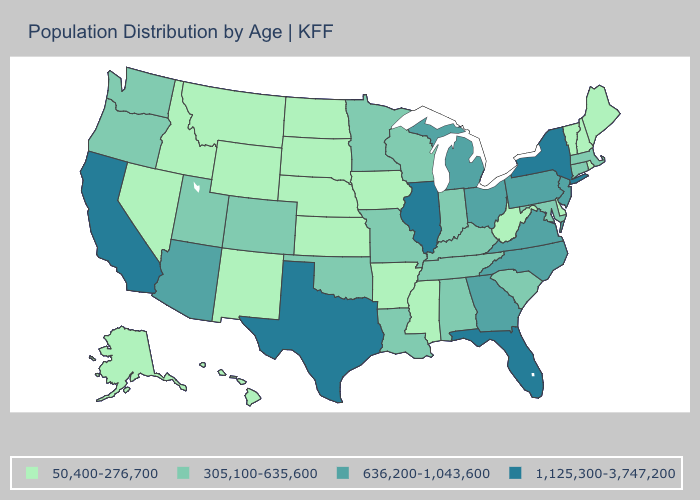Does the first symbol in the legend represent the smallest category?
Give a very brief answer. Yes. Does Washington have the lowest value in the West?
Answer briefly. No. What is the lowest value in the West?
Concise answer only. 50,400-276,700. What is the value of Idaho?
Short answer required. 50,400-276,700. Among the states that border Nebraska , which have the highest value?
Short answer required. Colorado, Missouri. Among the states that border Ohio , which have the lowest value?
Concise answer only. West Virginia. What is the highest value in the South ?
Short answer required. 1,125,300-3,747,200. How many symbols are there in the legend?
Short answer required. 4. What is the value of Louisiana?
Quick response, please. 305,100-635,600. What is the value of Oregon?
Quick response, please. 305,100-635,600. Which states have the highest value in the USA?
Give a very brief answer. California, Florida, Illinois, New York, Texas. Name the states that have a value in the range 305,100-635,600?
Concise answer only. Alabama, Colorado, Connecticut, Indiana, Kentucky, Louisiana, Maryland, Massachusetts, Minnesota, Missouri, Oklahoma, Oregon, South Carolina, Tennessee, Utah, Washington, Wisconsin. Among the states that border Tennessee , does Alabama have the highest value?
Give a very brief answer. No. What is the value of Wyoming?
Give a very brief answer. 50,400-276,700. Which states have the lowest value in the USA?
Answer briefly. Alaska, Arkansas, Delaware, Hawaii, Idaho, Iowa, Kansas, Maine, Mississippi, Montana, Nebraska, Nevada, New Hampshire, New Mexico, North Dakota, Rhode Island, South Dakota, Vermont, West Virginia, Wyoming. 